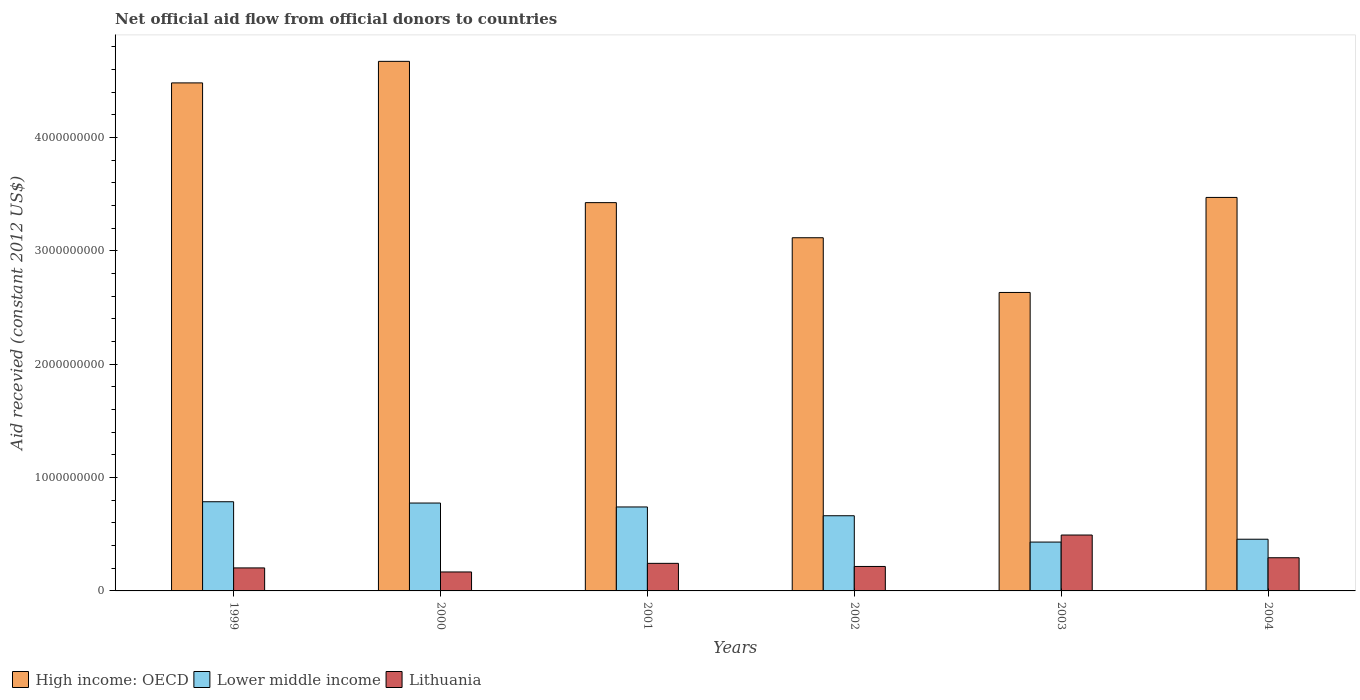How many groups of bars are there?
Your answer should be compact. 6. How many bars are there on the 6th tick from the right?
Provide a short and direct response. 3. In how many cases, is the number of bars for a given year not equal to the number of legend labels?
Ensure brevity in your answer.  0. What is the total aid received in Lithuania in 1999?
Offer a terse response. 2.03e+08. Across all years, what is the maximum total aid received in Lower middle income?
Provide a succinct answer. 7.87e+08. Across all years, what is the minimum total aid received in Lower middle income?
Your answer should be very brief. 4.31e+08. What is the total total aid received in Lithuania in the graph?
Your response must be concise. 1.62e+09. What is the difference between the total aid received in Lower middle income in 1999 and that in 2002?
Give a very brief answer. 1.23e+08. What is the difference between the total aid received in High income: OECD in 2003 and the total aid received in Lithuania in 2002?
Offer a very short reply. 2.42e+09. What is the average total aid received in Lower middle income per year?
Your response must be concise. 6.42e+08. In the year 1999, what is the difference between the total aid received in Lithuania and total aid received in Lower middle income?
Offer a very short reply. -5.84e+08. What is the ratio of the total aid received in Lithuania in 2001 to that in 2002?
Your response must be concise. 1.13. What is the difference between the highest and the second highest total aid received in High income: OECD?
Offer a very short reply. 1.90e+08. What is the difference between the highest and the lowest total aid received in Lithuania?
Keep it short and to the point. 3.26e+08. In how many years, is the total aid received in High income: OECD greater than the average total aid received in High income: OECD taken over all years?
Give a very brief answer. 2. Is the sum of the total aid received in Lithuania in 1999 and 2001 greater than the maximum total aid received in Lower middle income across all years?
Provide a short and direct response. No. What does the 3rd bar from the left in 2004 represents?
Offer a very short reply. Lithuania. What does the 3rd bar from the right in 2004 represents?
Give a very brief answer. High income: OECD. Is it the case that in every year, the sum of the total aid received in Lithuania and total aid received in Lower middle income is greater than the total aid received in High income: OECD?
Offer a terse response. No. How many years are there in the graph?
Offer a very short reply. 6. Are the values on the major ticks of Y-axis written in scientific E-notation?
Ensure brevity in your answer.  No. Does the graph contain any zero values?
Make the answer very short. No. Does the graph contain grids?
Offer a very short reply. No. Where does the legend appear in the graph?
Give a very brief answer. Bottom left. How many legend labels are there?
Provide a succinct answer. 3. How are the legend labels stacked?
Make the answer very short. Horizontal. What is the title of the graph?
Give a very brief answer. Net official aid flow from official donors to countries. Does "Bahrain" appear as one of the legend labels in the graph?
Your response must be concise. No. What is the label or title of the Y-axis?
Make the answer very short. Aid recevied (constant 2012 US$). What is the Aid recevied (constant 2012 US$) of High income: OECD in 1999?
Offer a very short reply. 4.48e+09. What is the Aid recevied (constant 2012 US$) of Lower middle income in 1999?
Make the answer very short. 7.87e+08. What is the Aid recevied (constant 2012 US$) of Lithuania in 1999?
Offer a very short reply. 2.03e+08. What is the Aid recevied (constant 2012 US$) of High income: OECD in 2000?
Your response must be concise. 4.67e+09. What is the Aid recevied (constant 2012 US$) in Lower middle income in 2000?
Offer a terse response. 7.75e+08. What is the Aid recevied (constant 2012 US$) of Lithuania in 2000?
Your answer should be compact. 1.67e+08. What is the Aid recevied (constant 2012 US$) of High income: OECD in 2001?
Offer a very short reply. 3.43e+09. What is the Aid recevied (constant 2012 US$) of Lower middle income in 2001?
Provide a succinct answer. 7.41e+08. What is the Aid recevied (constant 2012 US$) in Lithuania in 2001?
Provide a short and direct response. 2.43e+08. What is the Aid recevied (constant 2012 US$) in High income: OECD in 2002?
Keep it short and to the point. 3.12e+09. What is the Aid recevied (constant 2012 US$) of Lower middle income in 2002?
Make the answer very short. 6.63e+08. What is the Aid recevied (constant 2012 US$) in Lithuania in 2002?
Offer a terse response. 2.16e+08. What is the Aid recevied (constant 2012 US$) of High income: OECD in 2003?
Give a very brief answer. 2.63e+09. What is the Aid recevied (constant 2012 US$) of Lower middle income in 2003?
Make the answer very short. 4.31e+08. What is the Aid recevied (constant 2012 US$) of Lithuania in 2003?
Keep it short and to the point. 4.93e+08. What is the Aid recevied (constant 2012 US$) in High income: OECD in 2004?
Your answer should be very brief. 3.47e+09. What is the Aid recevied (constant 2012 US$) in Lower middle income in 2004?
Provide a succinct answer. 4.56e+08. What is the Aid recevied (constant 2012 US$) in Lithuania in 2004?
Offer a very short reply. 2.93e+08. Across all years, what is the maximum Aid recevied (constant 2012 US$) in High income: OECD?
Make the answer very short. 4.67e+09. Across all years, what is the maximum Aid recevied (constant 2012 US$) in Lower middle income?
Make the answer very short. 7.87e+08. Across all years, what is the maximum Aid recevied (constant 2012 US$) of Lithuania?
Your answer should be very brief. 4.93e+08. Across all years, what is the minimum Aid recevied (constant 2012 US$) of High income: OECD?
Make the answer very short. 2.63e+09. Across all years, what is the minimum Aid recevied (constant 2012 US$) in Lower middle income?
Keep it short and to the point. 4.31e+08. Across all years, what is the minimum Aid recevied (constant 2012 US$) of Lithuania?
Your answer should be very brief. 1.67e+08. What is the total Aid recevied (constant 2012 US$) in High income: OECD in the graph?
Your response must be concise. 2.18e+1. What is the total Aid recevied (constant 2012 US$) of Lower middle income in the graph?
Ensure brevity in your answer.  3.85e+09. What is the total Aid recevied (constant 2012 US$) of Lithuania in the graph?
Ensure brevity in your answer.  1.62e+09. What is the difference between the Aid recevied (constant 2012 US$) in High income: OECD in 1999 and that in 2000?
Your answer should be very brief. -1.90e+08. What is the difference between the Aid recevied (constant 2012 US$) in Lower middle income in 1999 and that in 2000?
Your answer should be very brief. 1.14e+07. What is the difference between the Aid recevied (constant 2012 US$) of Lithuania in 1999 and that in 2000?
Make the answer very short. 3.57e+07. What is the difference between the Aid recevied (constant 2012 US$) in High income: OECD in 1999 and that in 2001?
Offer a very short reply. 1.06e+09. What is the difference between the Aid recevied (constant 2012 US$) of Lower middle income in 1999 and that in 2001?
Your answer should be compact. 4.60e+07. What is the difference between the Aid recevied (constant 2012 US$) of Lithuania in 1999 and that in 2001?
Offer a very short reply. -4.03e+07. What is the difference between the Aid recevied (constant 2012 US$) of High income: OECD in 1999 and that in 2002?
Ensure brevity in your answer.  1.37e+09. What is the difference between the Aid recevied (constant 2012 US$) of Lower middle income in 1999 and that in 2002?
Provide a short and direct response. 1.23e+08. What is the difference between the Aid recevied (constant 2012 US$) of Lithuania in 1999 and that in 2002?
Ensure brevity in your answer.  -1.29e+07. What is the difference between the Aid recevied (constant 2012 US$) of High income: OECD in 1999 and that in 2003?
Offer a terse response. 1.85e+09. What is the difference between the Aid recevied (constant 2012 US$) of Lower middle income in 1999 and that in 2003?
Your answer should be very brief. 3.56e+08. What is the difference between the Aid recevied (constant 2012 US$) of Lithuania in 1999 and that in 2003?
Offer a terse response. -2.90e+08. What is the difference between the Aid recevied (constant 2012 US$) of High income: OECD in 1999 and that in 2004?
Keep it short and to the point. 1.01e+09. What is the difference between the Aid recevied (constant 2012 US$) of Lower middle income in 1999 and that in 2004?
Your answer should be compact. 3.31e+08. What is the difference between the Aid recevied (constant 2012 US$) of Lithuania in 1999 and that in 2004?
Make the answer very short. -8.97e+07. What is the difference between the Aid recevied (constant 2012 US$) of High income: OECD in 2000 and that in 2001?
Give a very brief answer. 1.25e+09. What is the difference between the Aid recevied (constant 2012 US$) in Lower middle income in 2000 and that in 2001?
Your response must be concise. 3.46e+07. What is the difference between the Aid recevied (constant 2012 US$) of Lithuania in 2000 and that in 2001?
Keep it short and to the point. -7.60e+07. What is the difference between the Aid recevied (constant 2012 US$) of High income: OECD in 2000 and that in 2002?
Keep it short and to the point. 1.56e+09. What is the difference between the Aid recevied (constant 2012 US$) of Lower middle income in 2000 and that in 2002?
Keep it short and to the point. 1.12e+08. What is the difference between the Aid recevied (constant 2012 US$) of Lithuania in 2000 and that in 2002?
Make the answer very short. -4.85e+07. What is the difference between the Aid recevied (constant 2012 US$) of High income: OECD in 2000 and that in 2003?
Offer a terse response. 2.04e+09. What is the difference between the Aid recevied (constant 2012 US$) of Lower middle income in 2000 and that in 2003?
Your response must be concise. 3.44e+08. What is the difference between the Aid recevied (constant 2012 US$) of Lithuania in 2000 and that in 2003?
Offer a terse response. -3.26e+08. What is the difference between the Aid recevied (constant 2012 US$) of High income: OECD in 2000 and that in 2004?
Ensure brevity in your answer.  1.20e+09. What is the difference between the Aid recevied (constant 2012 US$) of Lower middle income in 2000 and that in 2004?
Offer a very short reply. 3.19e+08. What is the difference between the Aid recevied (constant 2012 US$) in Lithuania in 2000 and that in 2004?
Your answer should be compact. -1.25e+08. What is the difference between the Aid recevied (constant 2012 US$) of High income: OECD in 2001 and that in 2002?
Your answer should be very brief. 3.10e+08. What is the difference between the Aid recevied (constant 2012 US$) in Lower middle income in 2001 and that in 2002?
Make the answer very short. 7.75e+07. What is the difference between the Aid recevied (constant 2012 US$) in Lithuania in 2001 and that in 2002?
Your response must be concise. 2.74e+07. What is the difference between the Aid recevied (constant 2012 US$) of High income: OECD in 2001 and that in 2003?
Offer a very short reply. 7.93e+08. What is the difference between the Aid recevied (constant 2012 US$) in Lower middle income in 2001 and that in 2003?
Offer a very short reply. 3.10e+08. What is the difference between the Aid recevied (constant 2012 US$) in Lithuania in 2001 and that in 2003?
Offer a terse response. -2.50e+08. What is the difference between the Aid recevied (constant 2012 US$) of High income: OECD in 2001 and that in 2004?
Offer a terse response. -4.60e+07. What is the difference between the Aid recevied (constant 2012 US$) in Lower middle income in 2001 and that in 2004?
Provide a short and direct response. 2.85e+08. What is the difference between the Aid recevied (constant 2012 US$) of Lithuania in 2001 and that in 2004?
Offer a very short reply. -4.95e+07. What is the difference between the Aid recevied (constant 2012 US$) in High income: OECD in 2002 and that in 2003?
Offer a very short reply. 4.83e+08. What is the difference between the Aid recevied (constant 2012 US$) in Lower middle income in 2002 and that in 2003?
Provide a succinct answer. 2.32e+08. What is the difference between the Aid recevied (constant 2012 US$) of Lithuania in 2002 and that in 2003?
Your answer should be very brief. -2.77e+08. What is the difference between the Aid recevied (constant 2012 US$) of High income: OECD in 2002 and that in 2004?
Offer a terse response. -3.56e+08. What is the difference between the Aid recevied (constant 2012 US$) of Lower middle income in 2002 and that in 2004?
Provide a short and direct response. 2.07e+08. What is the difference between the Aid recevied (constant 2012 US$) in Lithuania in 2002 and that in 2004?
Offer a very short reply. -7.69e+07. What is the difference between the Aid recevied (constant 2012 US$) of High income: OECD in 2003 and that in 2004?
Your response must be concise. -8.39e+08. What is the difference between the Aid recevied (constant 2012 US$) in Lower middle income in 2003 and that in 2004?
Provide a short and direct response. -2.51e+07. What is the difference between the Aid recevied (constant 2012 US$) of Lithuania in 2003 and that in 2004?
Your answer should be very brief. 2.01e+08. What is the difference between the Aid recevied (constant 2012 US$) in High income: OECD in 1999 and the Aid recevied (constant 2012 US$) in Lower middle income in 2000?
Your answer should be compact. 3.71e+09. What is the difference between the Aid recevied (constant 2012 US$) of High income: OECD in 1999 and the Aid recevied (constant 2012 US$) of Lithuania in 2000?
Provide a succinct answer. 4.32e+09. What is the difference between the Aid recevied (constant 2012 US$) of Lower middle income in 1999 and the Aid recevied (constant 2012 US$) of Lithuania in 2000?
Give a very brief answer. 6.20e+08. What is the difference between the Aid recevied (constant 2012 US$) in High income: OECD in 1999 and the Aid recevied (constant 2012 US$) in Lower middle income in 2001?
Ensure brevity in your answer.  3.74e+09. What is the difference between the Aid recevied (constant 2012 US$) in High income: OECD in 1999 and the Aid recevied (constant 2012 US$) in Lithuania in 2001?
Your answer should be very brief. 4.24e+09. What is the difference between the Aid recevied (constant 2012 US$) of Lower middle income in 1999 and the Aid recevied (constant 2012 US$) of Lithuania in 2001?
Provide a short and direct response. 5.44e+08. What is the difference between the Aid recevied (constant 2012 US$) of High income: OECD in 1999 and the Aid recevied (constant 2012 US$) of Lower middle income in 2002?
Your response must be concise. 3.82e+09. What is the difference between the Aid recevied (constant 2012 US$) in High income: OECD in 1999 and the Aid recevied (constant 2012 US$) in Lithuania in 2002?
Provide a short and direct response. 4.27e+09. What is the difference between the Aid recevied (constant 2012 US$) in Lower middle income in 1999 and the Aid recevied (constant 2012 US$) in Lithuania in 2002?
Provide a short and direct response. 5.71e+08. What is the difference between the Aid recevied (constant 2012 US$) of High income: OECD in 1999 and the Aid recevied (constant 2012 US$) of Lower middle income in 2003?
Your answer should be compact. 4.05e+09. What is the difference between the Aid recevied (constant 2012 US$) in High income: OECD in 1999 and the Aid recevied (constant 2012 US$) in Lithuania in 2003?
Your answer should be very brief. 3.99e+09. What is the difference between the Aid recevied (constant 2012 US$) of Lower middle income in 1999 and the Aid recevied (constant 2012 US$) of Lithuania in 2003?
Make the answer very short. 2.94e+08. What is the difference between the Aid recevied (constant 2012 US$) in High income: OECD in 1999 and the Aid recevied (constant 2012 US$) in Lower middle income in 2004?
Ensure brevity in your answer.  4.03e+09. What is the difference between the Aid recevied (constant 2012 US$) in High income: OECD in 1999 and the Aid recevied (constant 2012 US$) in Lithuania in 2004?
Give a very brief answer. 4.19e+09. What is the difference between the Aid recevied (constant 2012 US$) in Lower middle income in 1999 and the Aid recevied (constant 2012 US$) in Lithuania in 2004?
Provide a succinct answer. 4.94e+08. What is the difference between the Aid recevied (constant 2012 US$) of High income: OECD in 2000 and the Aid recevied (constant 2012 US$) of Lower middle income in 2001?
Provide a succinct answer. 3.93e+09. What is the difference between the Aid recevied (constant 2012 US$) in High income: OECD in 2000 and the Aid recevied (constant 2012 US$) in Lithuania in 2001?
Give a very brief answer. 4.43e+09. What is the difference between the Aid recevied (constant 2012 US$) in Lower middle income in 2000 and the Aid recevied (constant 2012 US$) in Lithuania in 2001?
Provide a short and direct response. 5.32e+08. What is the difference between the Aid recevied (constant 2012 US$) of High income: OECD in 2000 and the Aid recevied (constant 2012 US$) of Lower middle income in 2002?
Your response must be concise. 4.01e+09. What is the difference between the Aid recevied (constant 2012 US$) of High income: OECD in 2000 and the Aid recevied (constant 2012 US$) of Lithuania in 2002?
Your answer should be compact. 4.46e+09. What is the difference between the Aid recevied (constant 2012 US$) of Lower middle income in 2000 and the Aid recevied (constant 2012 US$) of Lithuania in 2002?
Provide a short and direct response. 5.60e+08. What is the difference between the Aid recevied (constant 2012 US$) in High income: OECD in 2000 and the Aid recevied (constant 2012 US$) in Lower middle income in 2003?
Provide a short and direct response. 4.24e+09. What is the difference between the Aid recevied (constant 2012 US$) in High income: OECD in 2000 and the Aid recevied (constant 2012 US$) in Lithuania in 2003?
Your answer should be very brief. 4.18e+09. What is the difference between the Aid recevied (constant 2012 US$) of Lower middle income in 2000 and the Aid recevied (constant 2012 US$) of Lithuania in 2003?
Provide a succinct answer. 2.82e+08. What is the difference between the Aid recevied (constant 2012 US$) in High income: OECD in 2000 and the Aid recevied (constant 2012 US$) in Lower middle income in 2004?
Provide a succinct answer. 4.22e+09. What is the difference between the Aid recevied (constant 2012 US$) in High income: OECD in 2000 and the Aid recevied (constant 2012 US$) in Lithuania in 2004?
Ensure brevity in your answer.  4.38e+09. What is the difference between the Aid recevied (constant 2012 US$) in Lower middle income in 2000 and the Aid recevied (constant 2012 US$) in Lithuania in 2004?
Your answer should be very brief. 4.83e+08. What is the difference between the Aid recevied (constant 2012 US$) in High income: OECD in 2001 and the Aid recevied (constant 2012 US$) in Lower middle income in 2002?
Offer a very short reply. 2.76e+09. What is the difference between the Aid recevied (constant 2012 US$) in High income: OECD in 2001 and the Aid recevied (constant 2012 US$) in Lithuania in 2002?
Your answer should be compact. 3.21e+09. What is the difference between the Aid recevied (constant 2012 US$) of Lower middle income in 2001 and the Aid recevied (constant 2012 US$) of Lithuania in 2002?
Ensure brevity in your answer.  5.25e+08. What is the difference between the Aid recevied (constant 2012 US$) in High income: OECD in 2001 and the Aid recevied (constant 2012 US$) in Lower middle income in 2003?
Keep it short and to the point. 3.00e+09. What is the difference between the Aid recevied (constant 2012 US$) of High income: OECD in 2001 and the Aid recevied (constant 2012 US$) of Lithuania in 2003?
Make the answer very short. 2.93e+09. What is the difference between the Aid recevied (constant 2012 US$) of Lower middle income in 2001 and the Aid recevied (constant 2012 US$) of Lithuania in 2003?
Ensure brevity in your answer.  2.48e+08. What is the difference between the Aid recevied (constant 2012 US$) in High income: OECD in 2001 and the Aid recevied (constant 2012 US$) in Lower middle income in 2004?
Your answer should be compact. 2.97e+09. What is the difference between the Aid recevied (constant 2012 US$) of High income: OECD in 2001 and the Aid recevied (constant 2012 US$) of Lithuania in 2004?
Make the answer very short. 3.13e+09. What is the difference between the Aid recevied (constant 2012 US$) of Lower middle income in 2001 and the Aid recevied (constant 2012 US$) of Lithuania in 2004?
Your response must be concise. 4.48e+08. What is the difference between the Aid recevied (constant 2012 US$) of High income: OECD in 2002 and the Aid recevied (constant 2012 US$) of Lower middle income in 2003?
Offer a terse response. 2.69e+09. What is the difference between the Aid recevied (constant 2012 US$) of High income: OECD in 2002 and the Aid recevied (constant 2012 US$) of Lithuania in 2003?
Your answer should be compact. 2.62e+09. What is the difference between the Aid recevied (constant 2012 US$) of Lower middle income in 2002 and the Aid recevied (constant 2012 US$) of Lithuania in 2003?
Provide a succinct answer. 1.70e+08. What is the difference between the Aid recevied (constant 2012 US$) of High income: OECD in 2002 and the Aid recevied (constant 2012 US$) of Lower middle income in 2004?
Make the answer very short. 2.66e+09. What is the difference between the Aid recevied (constant 2012 US$) of High income: OECD in 2002 and the Aid recevied (constant 2012 US$) of Lithuania in 2004?
Give a very brief answer. 2.82e+09. What is the difference between the Aid recevied (constant 2012 US$) in Lower middle income in 2002 and the Aid recevied (constant 2012 US$) in Lithuania in 2004?
Offer a terse response. 3.71e+08. What is the difference between the Aid recevied (constant 2012 US$) of High income: OECD in 2003 and the Aid recevied (constant 2012 US$) of Lower middle income in 2004?
Your answer should be very brief. 2.18e+09. What is the difference between the Aid recevied (constant 2012 US$) of High income: OECD in 2003 and the Aid recevied (constant 2012 US$) of Lithuania in 2004?
Give a very brief answer. 2.34e+09. What is the difference between the Aid recevied (constant 2012 US$) of Lower middle income in 2003 and the Aid recevied (constant 2012 US$) of Lithuania in 2004?
Offer a very short reply. 1.38e+08. What is the average Aid recevied (constant 2012 US$) of High income: OECD per year?
Your response must be concise. 3.63e+09. What is the average Aid recevied (constant 2012 US$) of Lower middle income per year?
Ensure brevity in your answer.  6.42e+08. What is the average Aid recevied (constant 2012 US$) of Lithuania per year?
Provide a short and direct response. 2.69e+08. In the year 1999, what is the difference between the Aid recevied (constant 2012 US$) in High income: OECD and Aid recevied (constant 2012 US$) in Lower middle income?
Offer a very short reply. 3.70e+09. In the year 1999, what is the difference between the Aid recevied (constant 2012 US$) of High income: OECD and Aid recevied (constant 2012 US$) of Lithuania?
Your answer should be very brief. 4.28e+09. In the year 1999, what is the difference between the Aid recevied (constant 2012 US$) of Lower middle income and Aid recevied (constant 2012 US$) of Lithuania?
Provide a short and direct response. 5.84e+08. In the year 2000, what is the difference between the Aid recevied (constant 2012 US$) in High income: OECD and Aid recevied (constant 2012 US$) in Lower middle income?
Give a very brief answer. 3.90e+09. In the year 2000, what is the difference between the Aid recevied (constant 2012 US$) in High income: OECD and Aid recevied (constant 2012 US$) in Lithuania?
Provide a short and direct response. 4.51e+09. In the year 2000, what is the difference between the Aid recevied (constant 2012 US$) in Lower middle income and Aid recevied (constant 2012 US$) in Lithuania?
Provide a succinct answer. 6.08e+08. In the year 2001, what is the difference between the Aid recevied (constant 2012 US$) in High income: OECD and Aid recevied (constant 2012 US$) in Lower middle income?
Offer a terse response. 2.69e+09. In the year 2001, what is the difference between the Aid recevied (constant 2012 US$) in High income: OECD and Aid recevied (constant 2012 US$) in Lithuania?
Ensure brevity in your answer.  3.18e+09. In the year 2001, what is the difference between the Aid recevied (constant 2012 US$) in Lower middle income and Aid recevied (constant 2012 US$) in Lithuania?
Your answer should be compact. 4.98e+08. In the year 2002, what is the difference between the Aid recevied (constant 2012 US$) in High income: OECD and Aid recevied (constant 2012 US$) in Lower middle income?
Your answer should be very brief. 2.45e+09. In the year 2002, what is the difference between the Aid recevied (constant 2012 US$) of High income: OECD and Aid recevied (constant 2012 US$) of Lithuania?
Keep it short and to the point. 2.90e+09. In the year 2002, what is the difference between the Aid recevied (constant 2012 US$) of Lower middle income and Aid recevied (constant 2012 US$) of Lithuania?
Your response must be concise. 4.48e+08. In the year 2003, what is the difference between the Aid recevied (constant 2012 US$) of High income: OECD and Aid recevied (constant 2012 US$) of Lower middle income?
Keep it short and to the point. 2.20e+09. In the year 2003, what is the difference between the Aid recevied (constant 2012 US$) of High income: OECD and Aid recevied (constant 2012 US$) of Lithuania?
Your response must be concise. 2.14e+09. In the year 2003, what is the difference between the Aid recevied (constant 2012 US$) in Lower middle income and Aid recevied (constant 2012 US$) in Lithuania?
Offer a terse response. -6.22e+07. In the year 2004, what is the difference between the Aid recevied (constant 2012 US$) of High income: OECD and Aid recevied (constant 2012 US$) of Lower middle income?
Ensure brevity in your answer.  3.02e+09. In the year 2004, what is the difference between the Aid recevied (constant 2012 US$) of High income: OECD and Aid recevied (constant 2012 US$) of Lithuania?
Make the answer very short. 3.18e+09. In the year 2004, what is the difference between the Aid recevied (constant 2012 US$) in Lower middle income and Aid recevied (constant 2012 US$) in Lithuania?
Make the answer very short. 1.63e+08. What is the ratio of the Aid recevied (constant 2012 US$) in High income: OECD in 1999 to that in 2000?
Your answer should be compact. 0.96. What is the ratio of the Aid recevied (constant 2012 US$) of Lower middle income in 1999 to that in 2000?
Make the answer very short. 1.01. What is the ratio of the Aid recevied (constant 2012 US$) of Lithuania in 1999 to that in 2000?
Give a very brief answer. 1.21. What is the ratio of the Aid recevied (constant 2012 US$) in High income: OECD in 1999 to that in 2001?
Make the answer very short. 1.31. What is the ratio of the Aid recevied (constant 2012 US$) of Lower middle income in 1999 to that in 2001?
Provide a succinct answer. 1.06. What is the ratio of the Aid recevied (constant 2012 US$) of Lithuania in 1999 to that in 2001?
Provide a short and direct response. 0.83. What is the ratio of the Aid recevied (constant 2012 US$) in High income: OECD in 1999 to that in 2002?
Provide a succinct answer. 1.44. What is the ratio of the Aid recevied (constant 2012 US$) of Lower middle income in 1999 to that in 2002?
Your answer should be very brief. 1.19. What is the ratio of the Aid recevied (constant 2012 US$) of Lithuania in 1999 to that in 2002?
Provide a short and direct response. 0.94. What is the ratio of the Aid recevied (constant 2012 US$) in High income: OECD in 1999 to that in 2003?
Provide a short and direct response. 1.7. What is the ratio of the Aid recevied (constant 2012 US$) in Lower middle income in 1999 to that in 2003?
Offer a very short reply. 1.83. What is the ratio of the Aid recevied (constant 2012 US$) of Lithuania in 1999 to that in 2003?
Keep it short and to the point. 0.41. What is the ratio of the Aid recevied (constant 2012 US$) in High income: OECD in 1999 to that in 2004?
Give a very brief answer. 1.29. What is the ratio of the Aid recevied (constant 2012 US$) of Lower middle income in 1999 to that in 2004?
Make the answer very short. 1.72. What is the ratio of the Aid recevied (constant 2012 US$) in Lithuania in 1999 to that in 2004?
Offer a terse response. 0.69. What is the ratio of the Aid recevied (constant 2012 US$) of High income: OECD in 2000 to that in 2001?
Give a very brief answer. 1.36. What is the ratio of the Aid recevied (constant 2012 US$) of Lower middle income in 2000 to that in 2001?
Your response must be concise. 1.05. What is the ratio of the Aid recevied (constant 2012 US$) in Lithuania in 2000 to that in 2001?
Give a very brief answer. 0.69. What is the ratio of the Aid recevied (constant 2012 US$) in High income: OECD in 2000 to that in 2002?
Your answer should be very brief. 1.5. What is the ratio of the Aid recevied (constant 2012 US$) of Lower middle income in 2000 to that in 2002?
Give a very brief answer. 1.17. What is the ratio of the Aid recevied (constant 2012 US$) in Lithuania in 2000 to that in 2002?
Keep it short and to the point. 0.78. What is the ratio of the Aid recevied (constant 2012 US$) in High income: OECD in 2000 to that in 2003?
Your response must be concise. 1.77. What is the ratio of the Aid recevied (constant 2012 US$) in Lower middle income in 2000 to that in 2003?
Make the answer very short. 1.8. What is the ratio of the Aid recevied (constant 2012 US$) in Lithuania in 2000 to that in 2003?
Your answer should be very brief. 0.34. What is the ratio of the Aid recevied (constant 2012 US$) in High income: OECD in 2000 to that in 2004?
Your response must be concise. 1.35. What is the ratio of the Aid recevied (constant 2012 US$) in Lower middle income in 2000 to that in 2004?
Offer a very short reply. 1.7. What is the ratio of the Aid recevied (constant 2012 US$) of Lithuania in 2000 to that in 2004?
Provide a short and direct response. 0.57. What is the ratio of the Aid recevied (constant 2012 US$) of High income: OECD in 2001 to that in 2002?
Provide a succinct answer. 1.1. What is the ratio of the Aid recevied (constant 2012 US$) of Lower middle income in 2001 to that in 2002?
Offer a very short reply. 1.12. What is the ratio of the Aid recevied (constant 2012 US$) in Lithuania in 2001 to that in 2002?
Offer a very short reply. 1.13. What is the ratio of the Aid recevied (constant 2012 US$) of High income: OECD in 2001 to that in 2003?
Make the answer very short. 1.3. What is the ratio of the Aid recevied (constant 2012 US$) in Lower middle income in 2001 to that in 2003?
Your response must be concise. 1.72. What is the ratio of the Aid recevied (constant 2012 US$) of Lithuania in 2001 to that in 2003?
Your answer should be very brief. 0.49. What is the ratio of the Aid recevied (constant 2012 US$) in Lower middle income in 2001 to that in 2004?
Offer a terse response. 1.62. What is the ratio of the Aid recevied (constant 2012 US$) in Lithuania in 2001 to that in 2004?
Your answer should be compact. 0.83. What is the ratio of the Aid recevied (constant 2012 US$) in High income: OECD in 2002 to that in 2003?
Provide a succinct answer. 1.18. What is the ratio of the Aid recevied (constant 2012 US$) of Lower middle income in 2002 to that in 2003?
Give a very brief answer. 1.54. What is the ratio of the Aid recevied (constant 2012 US$) of Lithuania in 2002 to that in 2003?
Make the answer very short. 0.44. What is the ratio of the Aid recevied (constant 2012 US$) of High income: OECD in 2002 to that in 2004?
Provide a short and direct response. 0.9. What is the ratio of the Aid recevied (constant 2012 US$) of Lower middle income in 2002 to that in 2004?
Your answer should be very brief. 1.45. What is the ratio of the Aid recevied (constant 2012 US$) of Lithuania in 2002 to that in 2004?
Your answer should be very brief. 0.74. What is the ratio of the Aid recevied (constant 2012 US$) of High income: OECD in 2003 to that in 2004?
Provide a succinct answer. 0.76. What is the ratio of the Aid recevied (constant 2012 US$) of Lower middle income in 2003 to that in 2004?
Ensure brevity in your answer.  0.94. What is the ratio of the Aid recevied (constant 2012 US$) of Lithuania in 2003 to that in 2004?
Ensure brevity in your answer.  1.69. What is the difference between the highest and the second highest Aid recevied (constant 2012 US$) of High income: OECD?
Ensure brevity in your answer.  1.90e+08. What is the difference between the highest and the second highest Aid recevied (constant 2012 US$) in Lower middle income?
Your response must be concise. 1.14e+07. What is the difference between the highest and the second highest Aid recevied (constant 2012 US$) of Lithuania?
Provide a short and direct response. 2.01e+08. What is the difference between the highest and the lowest Aid recevied (constant 2012 US$) in High income: OECD?
Your response must be concise. 2.04e+09. What is the difference between the highest and the lowest Aid recevied (constant 2012 US$) in Lower middle income?
Provide a succinct answer. 3.56e+08. What is the difference between the highest and the lowest Aid recevied (constant 2012 US$) of Lithuania?
Provide a short and direct response. 3.26e+08. 